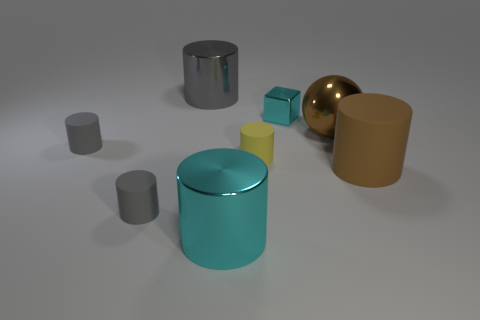There is a matte object that is right of the small matte cylinder that is right of the large gray object; are there any rubber things that are behind it? In the image, I can see various objects, but without additional context or material properties, I cannot accurately confirm the presence of rubber materials. Behind the teal cylinder, which is to the right of the small gray cylinder and the larger gray object, no objects are visually identifiable. Therefore, to the best of my knowledge based on the image, there do not appear to be any rubber things directly behind the teal cylinder. 